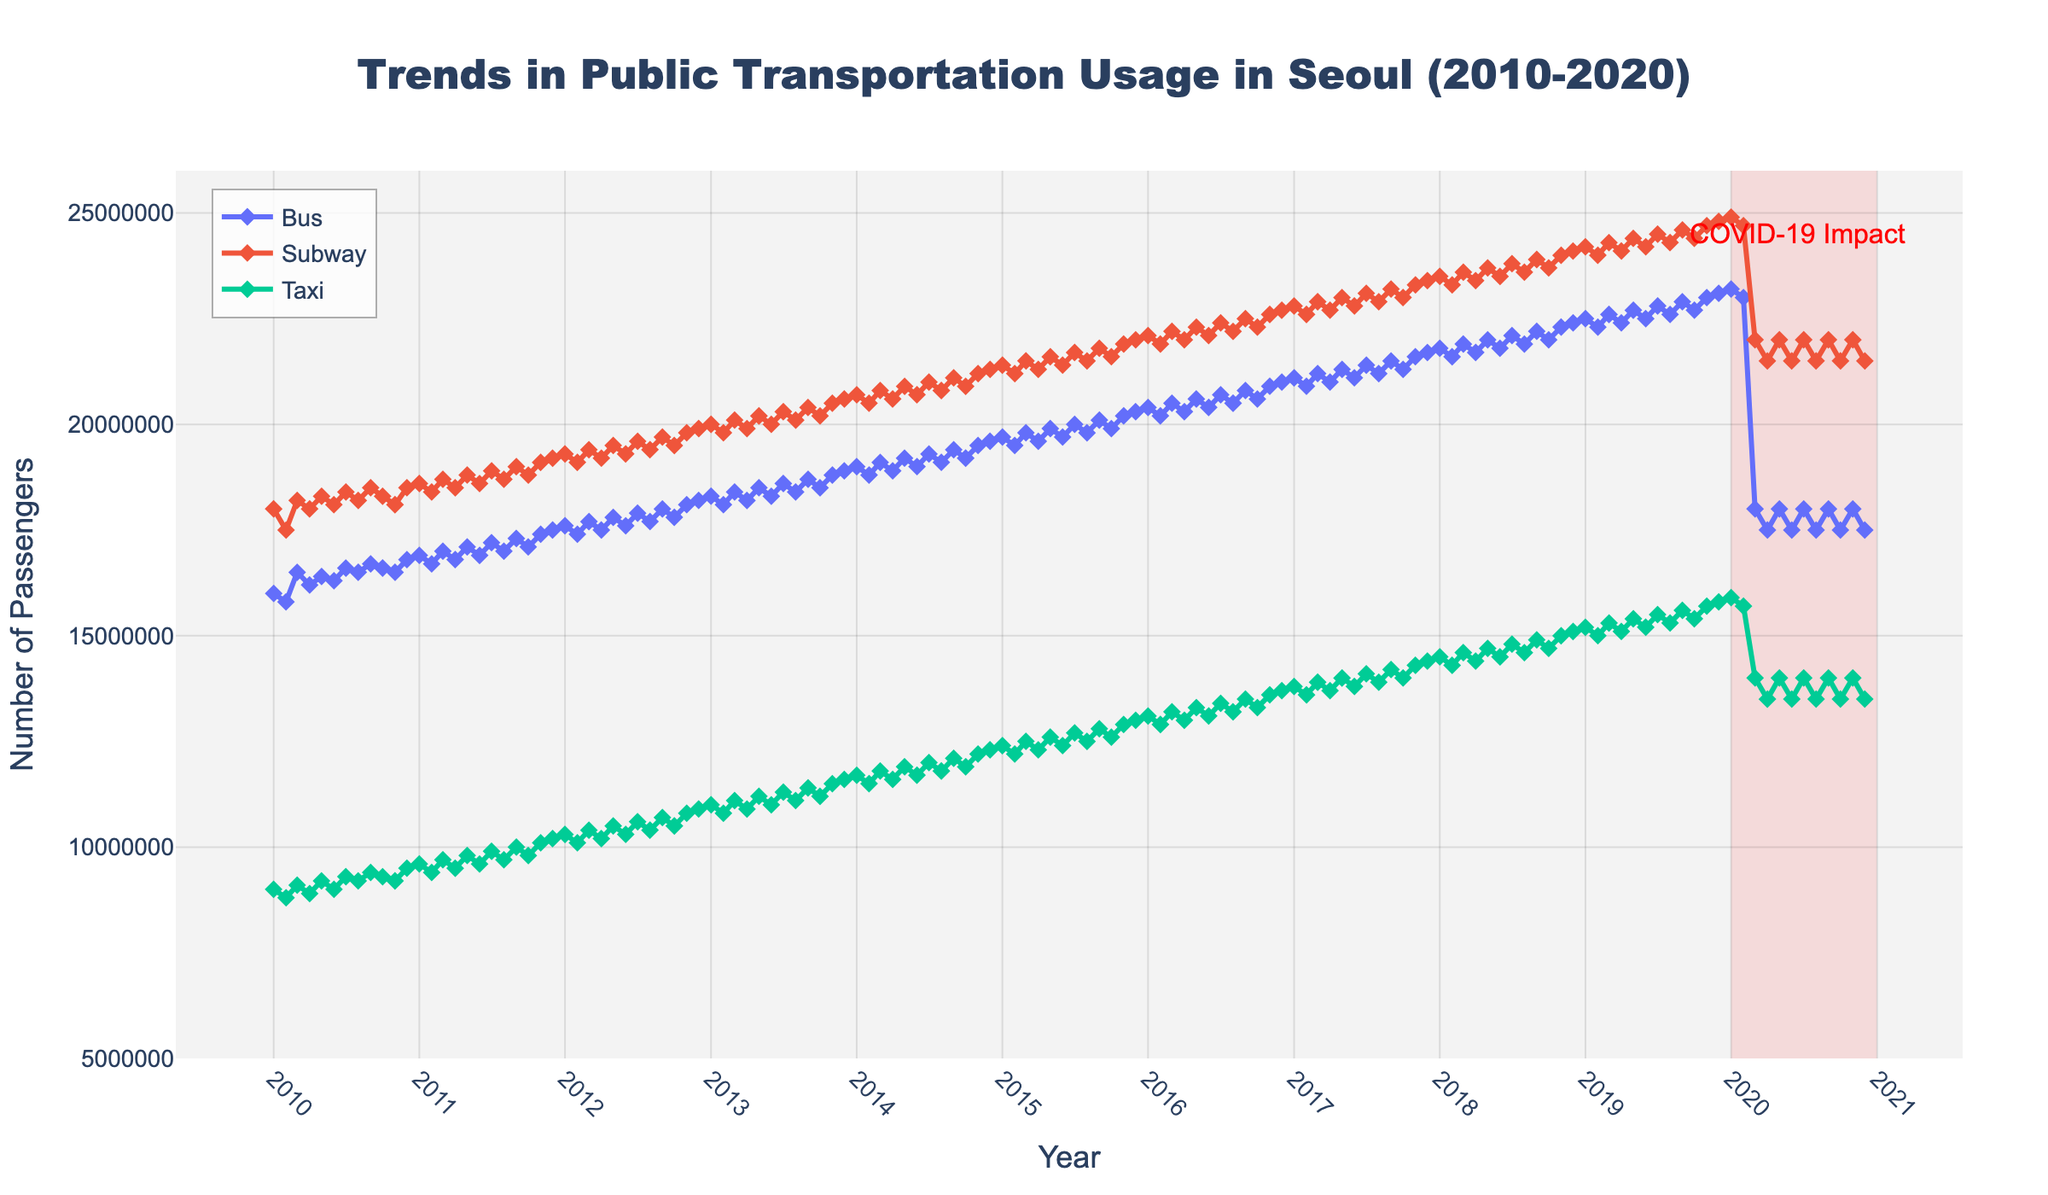What time period does the highlighted red rectangular area represent? The red rectangle is meant to highlight data during the COVID-19 pandemic period. By observing the dates marked at the horizontal extremities of the red rectangle, one can see that it spans from January 2020 to December 2020.
Answer: January 2020 to December 2020 Which mode of transportation had the highest number of passengers in January 2015? Look for January 2015 on the x-axis and then compare the heights of the marked points for Bus, Subway, and Taxi. The Subway trace (represented by the line and marker) is the highest among the three for this month.
Answer: Subway How did the number of taxi passengers change from January 2010 to January 2020? At January 2010, the number of taxi passengers was 9,000,000. By January 2020, it had risen to 15,900,000. The increase can be calculated by subtracting the earlier number from the later number: (15,900,000 - 9,000,000)
Answer: Increased by 6,900,000 During which month and year did the subway reach a peak in ridership, and what was the number? Observe the entire Subway trace and identify the highest point. This peak corresponds to December 2020, where the number of passengers is noted at 24,900,000.
Answer: December 2020, 24,900,000 What is the average number of bus passengers for the years 2015 and 2016? Identify all the bus data points from January 2015 to December 2016, sum them up and divide by the number of data points (24 months). Average = (Sum of bus passengers from January 2015 to December 2016) / 24. The sum can be calculated as follows: (19700000 + 19500000 + 19800000 + 19600000 + 19900000 + 19700000 + 20000000 + 19800000 + 20100000 + 19900000 + 20200000 + 20300000 + 20400000 + 20200000 + 20500000 + 20300000 + 20600000 + 20400000 + 20700000 + 20500000 + 20800000 + 20600000 + 20900000 + 21000000) / 24
Answer: Approximately 20,275,000 Which mode of transportation shows the most significant drop in passengers between February 2020 and March 2020, and what is the difference? Examine the data points for February 2020 and March 2020 for Bus, Subway, and Taxi. Calculate the differences: 
1. Bus: 23,000,000 - 18,000,000 
2. Subway: 24,700,000 - 22,000,000 
3. Taxi: 15,700,000 - 14,000,000
The Bus mode shows the largest decrease.
Answer: Bus, difference of 5,000,000 How does the Subway ridership in July 2020 compare to July 2019? Identify and compare the data points. 
1. July 2020: 22,000,000 
2. July 2019: 24,500,000
Subway ridership in July 2020 is less than in July 2019.
Answer: Less by 2,500,000 What overall trend do you observe in the usage of public transportation modes in Seoul from 2010 to 2019? Observe the general direction of the traces for Bus, Subway, and Taxi from 2010 to 2019. All three transportation modes show an overall increasing trend over these years.
Answer: Increasing trend Which mode of transportation had the least number of passengers in April 2013, and what was the number? Find April 2013 on the x-axis and compare the heights of the markers for Bus, Subway, and Taxi. The Taxi mode has the lowest placement.
Answer: Taxi, 10,900,000 What was the percentage drop in subway passengers from January 2020 to February 2020? Check the values:
1. January 2020: 24,900,000
2. February 2020: 24,700,000
Difference is 24,900,000 - 24,700,000 = 200,000
Percentage drop: (200,000 / 24,900,000) * 100
Answer: Approximately 0.8% 